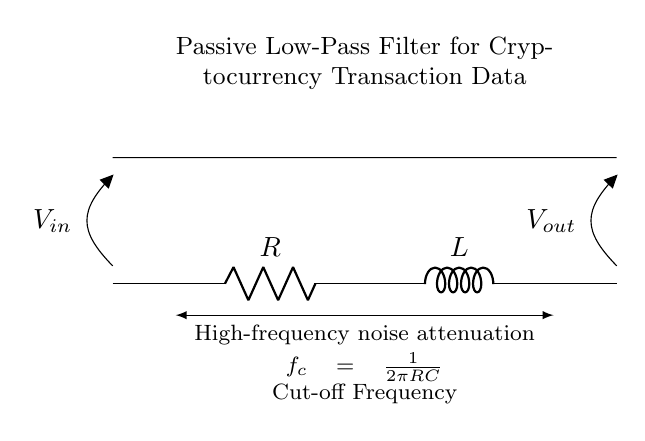What are the components in the circuit? The components are a resistor and an inductor, as indicated by the symbols R and L in the diagram.
Answer: Resistor and Inductor What does "V_in" represent? "V_in" represents the input voltage in the circuit, as shown at the left side of the diagram, labeled with a voltage source indicator.
Answer: Input voltage What is the cut-off frequency formula? The cut-off frequency formula is provided in the diagram as \( f_c = \frac{1}{2\pi RC} \), indicating how it is calculated based on resistor and capacitor values.
Answer: f_c = 1/(2πRC) How does this circuit filter noise? The circuit filters noise by attenuating high-frequency signals while allowing low-frequency signals to pass through, based on the characteristics of the low-pass filter design.
Answer: Attenuates high-frequency signals What is the function of the resistor? The function of the resistor is to limit the current flowing through the circuit, which helps to define the cut-off frequency along with the inductor.
Answer: Limit current What does the high-frequency noise attenuation signify? High-frequency noise attenuation signifies that the circuit is designed to reduce the impact of high-frequency signals, thus improving the quality of the transmitted data.
Answer: Reduces impact of high frequencies Is this circuit a passive or active filter? This circuit is a passive filter, as it consists only of passive components (resistor and inductor) and does not require an external power source for operation.
Answer: Passive filter 